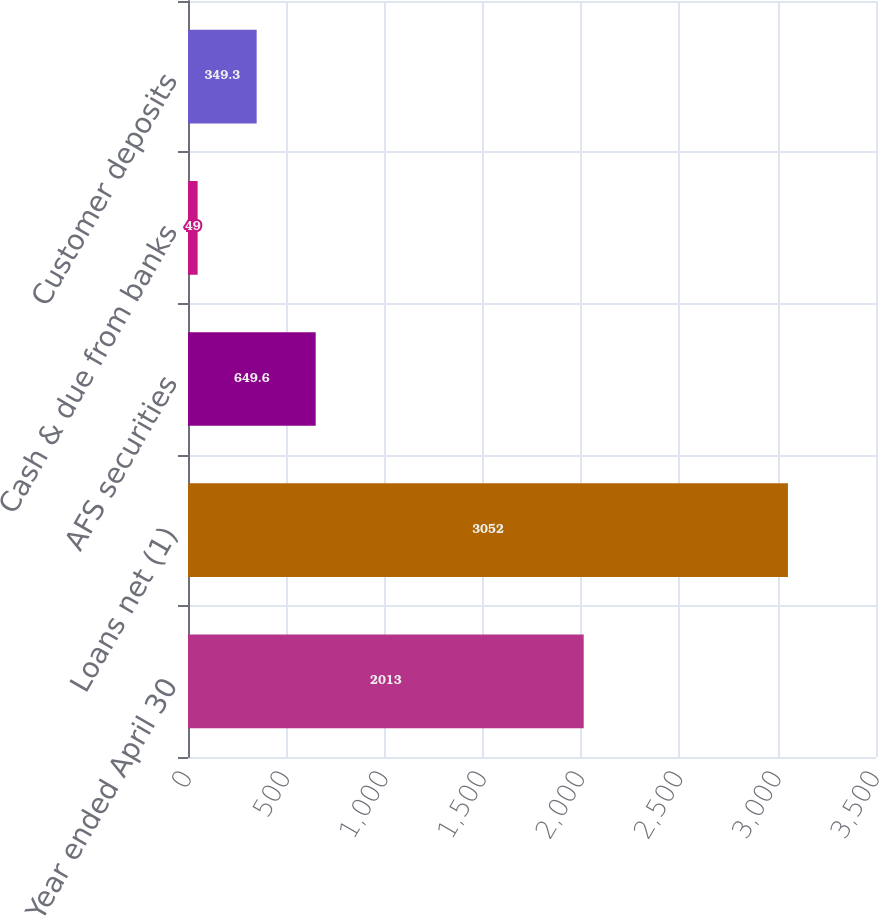Convert chart to OTSL. <chart><loc_0><loc_0><loc_500><loc_500><bar_chart><fcel>Year ended April 30<fcel>Loans net (1)<fcel>AFS securities<fcel>Cash & due from banks<fcel>Customer deposits<nl><fcel>2013<fcel>3052<fcel>649.6<fcel>49<fcel>349.3<nl></chart> 